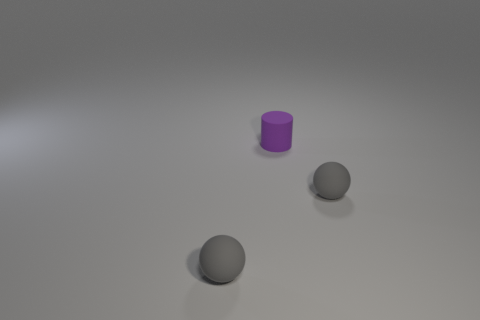Are there any other things that are the same shape as the small purple rubber object?
Offer a terse response. No. There is a tiny purple matte thing; does it have the same shape as the small gray matte object that is on the left side of the small rubber cylinder?
Provide a succinct answer. No. What number of things are tiny balls in front of the cylinder or tiny gray matte balls to the left of the purple object?
Keep it short and to the point. 2. What is the material of the purple cylinder?
Make the answer very short. Rubber. What number of other objects are the same size as the purple cylinder?
Your response must be concise. 2. There is a gray matte object that is left of the tiny rubber cylinder; how big is it?
Offer a very short reply. Small. What is the material of the small object left of the purple object that is to the right of the tiny matte ball to the left of the tiny purple object?
Provide a succinct answer. Rubber. How many rubber objects are either spheres or tiny purple things?
Provide a succinct answer. 3. What number of purple matte things are there?
Offer a very short reply. 1. There is a purple cylinder; does it have the same size as the thing that is on the right side of the cylinder?
Offer a terse response. Yes. 